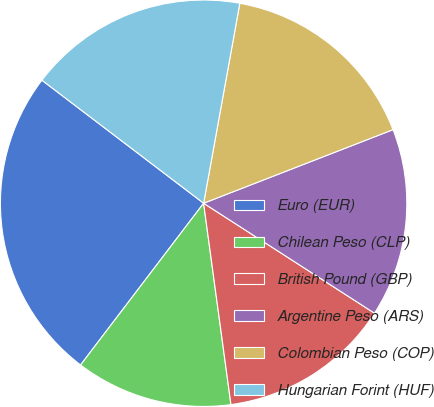Convert chart. <chart><loc_0><loc_0><loc_500><loc_500><pie_chart><fcel>Euro (EUR)<fcel>Chilean Peso (CLP)<fcel>British Pound (GBP)<fcel>Argentine Peso (ARS)<fcel>Colombian Peso (COP)<fcel>Hungarian Forint (HUF)<nl><fcel>25.0%<fcel>12.5%<fcel>13.75%<fcel>15.0%<fcel>16.25%<fcel>17.5%<nl></chart> 